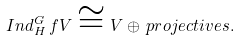<formula> <loc_0><loc_0><loc_500><loc_500>I n d _ { H } ^ { G } \, f V \cong V \oplus \, p r o j e c t i v e s .</formula> 